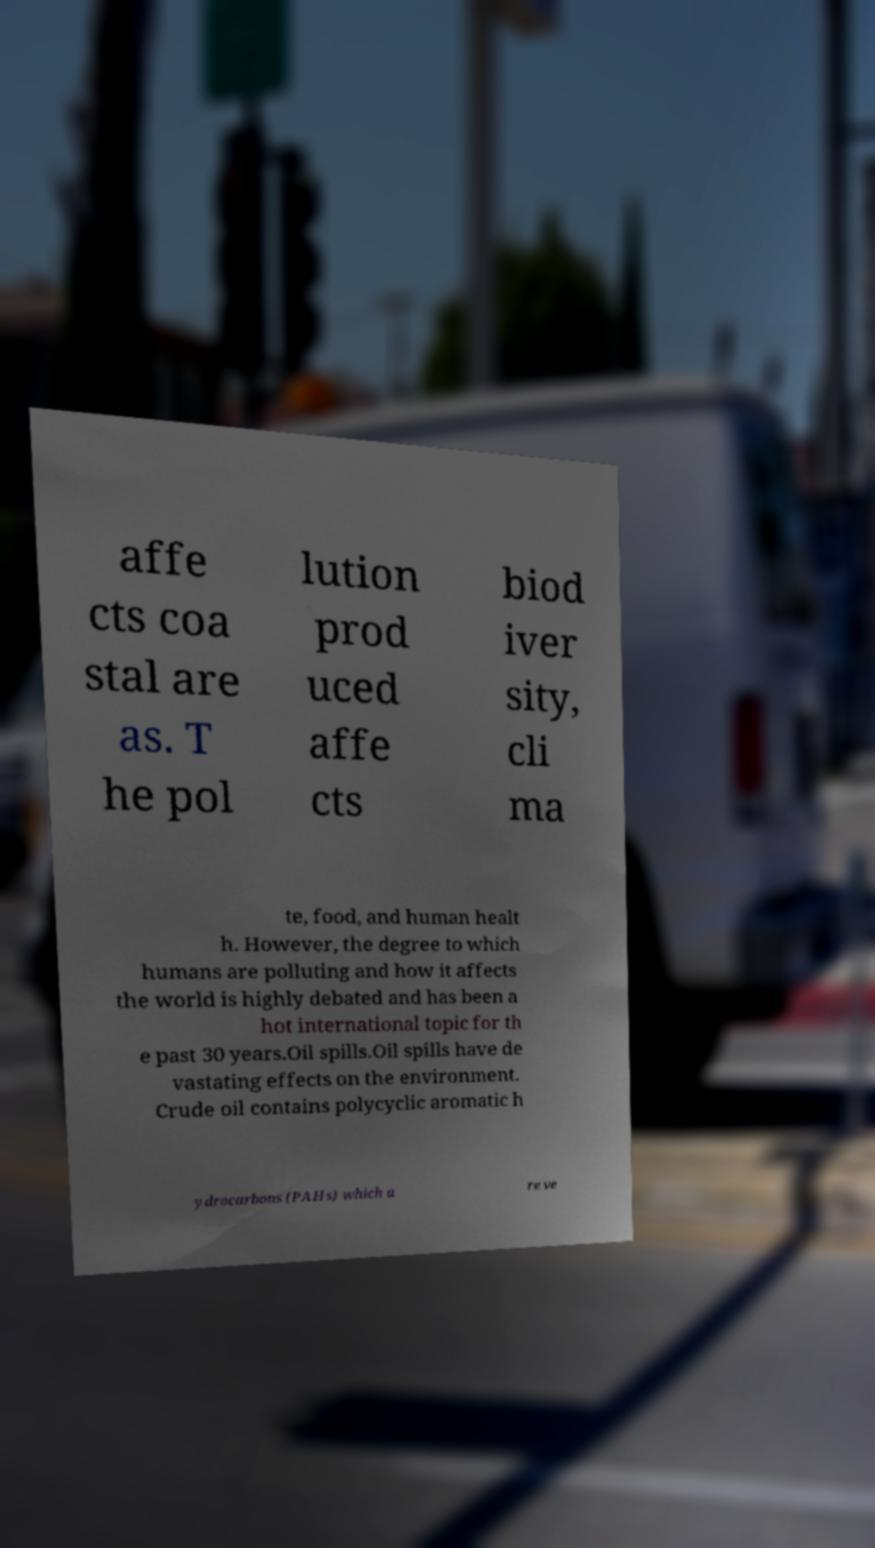Please read and relay the text visible in this image. What does it say? affe cts coa stal are as. T he pol lution prod uced affe cts biod iver sity, cli ma te, food, and human healt h. However, the degree to which humans are polluting and how it affects the world is highly debated and has been a hot international topic for th e past 30 years.Oil spills.Oil spills have de vastating effects on the environment. Crude oil contains polycyclic aromatic h ydrocarbons (PAHs) which a re ve 